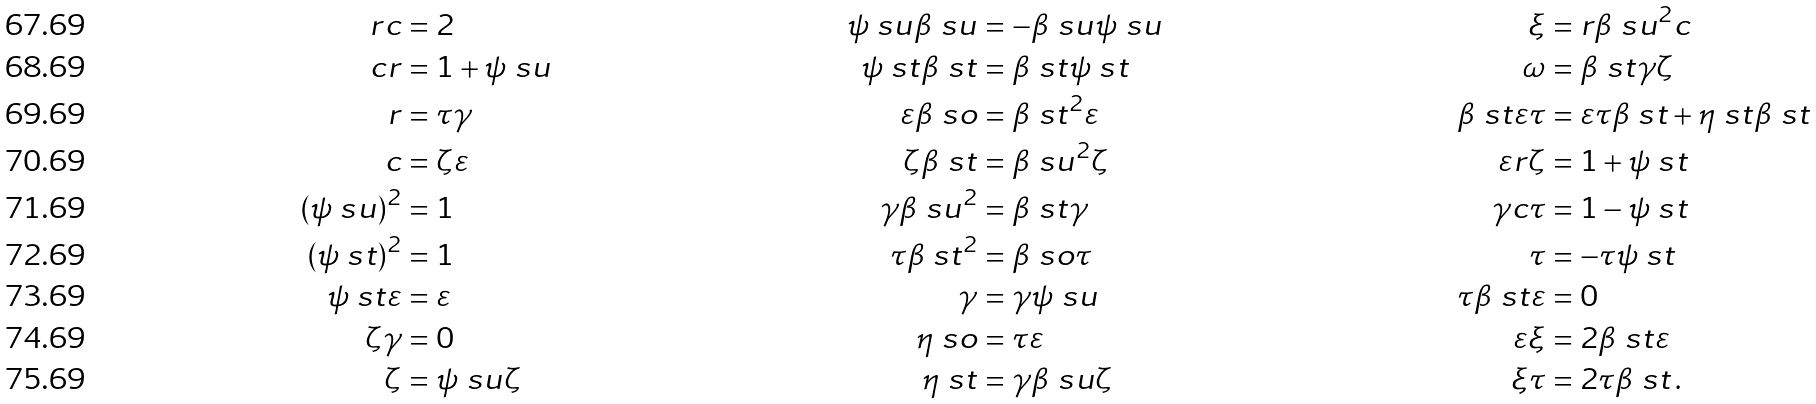Convert formula to latex. <formula><loc_0><loc_0><loc_500><loc_500>r c & = 2 & \psi \ s u \beta \ s u & = - \beta \ s u \psi \ s u & \xi & = r \beta \ s u ^ { 2 } c \\ c r & = 1 + \psi \ s u & \psi \ s t \beta \ s t & = \beta \ s t \psi \ s t & \omega & = \beta \ s t \gamma \zeta \\ r & = \tau \gamma & \varepsilon \beta \ s o & = \beta \ s t ^ { 2 } \varepsilon & \beta \ s t \varepsilon \tau & = \varepsilon \tau \beta \ s t + \eta \ s t \beta \ s t \\ c & = \zeta \varepsilon & \zeta \beta \ s t & = \beta \ s u ^ { 2 } \zeta & \varepsilon r \zeta & = 1 + \psi \ s t \\ ( \psi \ s u ) ^ { 2 } & = 1 & \gamma \beta \ s u ^ { 2 } & = \beta \ s t \gamma & \gamma c \tau & = 1 - \psi \ s t \\ ( \psi \ s t ) ^ { 2 } & = 1 & \tau \beta \ s t ^ { 2 } & = \beta \ s o \tau & \tau & = - \tau \psi \ s t \\ \psi \ s t \varepsilon & = \varepsilon & \gamma & = \gamma \psi \ s u \quad & \tau \beta \ s t \varepsilon & = 0 \\ \zeta \gamma & = 0 & \eta \ s o & = \tau \varepsilon & \varepsilon \xi & = 2 \beta \ s t \varepsilon \\ \zeta & = \psi \ s u \zeta & \eta \ s t & = \gamma \beta \ s u \zeta & \xi \tau & = 2 \tau \beta \ s t \, .</formula> 